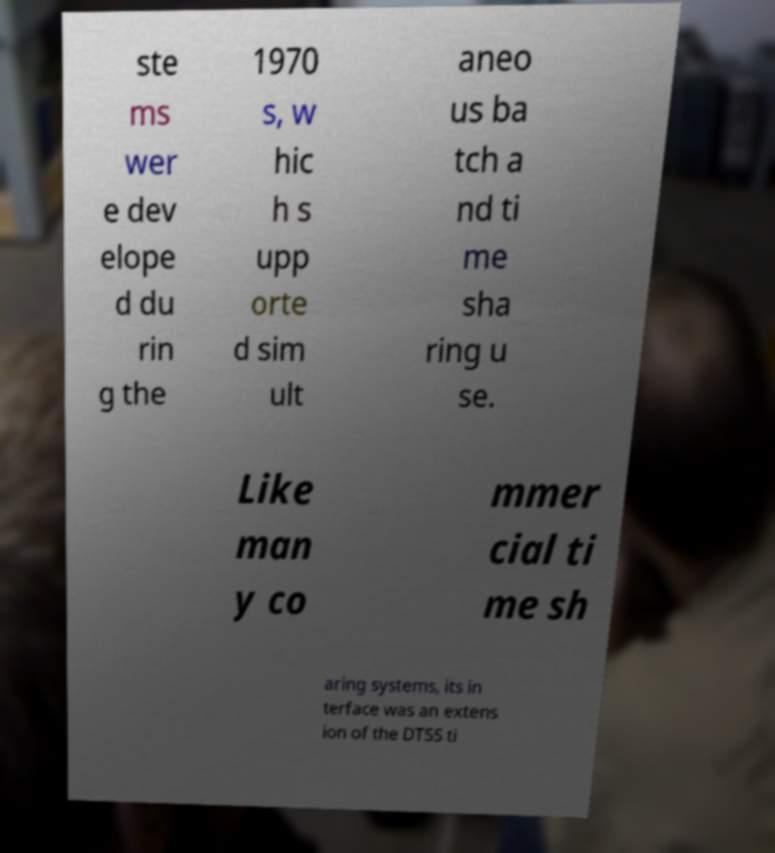I need the written content from this picture converted into text. Can you do that? ste ms wer e dev elope d du rin g the 1970 s, w hic h s upp orte d sim ult aneo us ba tch a nd ti me sha ring u se. Like man y co mmer cial ti me sh aring systems, its in terface was an extens ion of the DTSS ti 